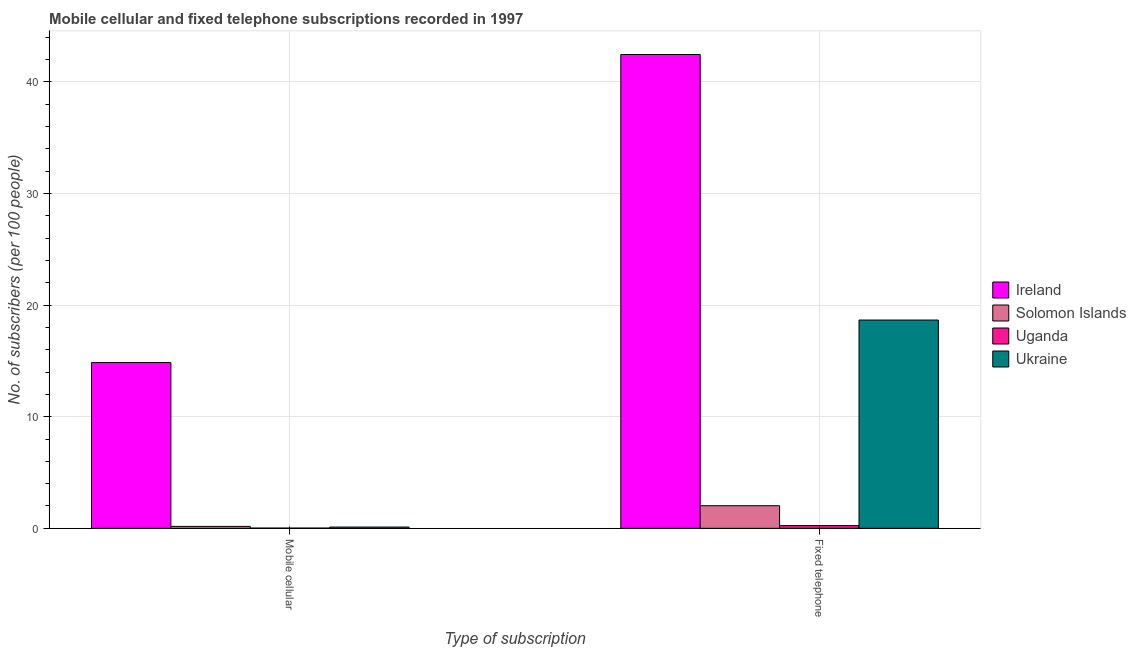Are the number of bars per tick equal to the number of legend labels?
Provide a short and direct response. Yes. How many bars are there on the 1st tick from the left?
Your answer should be compact. 4. What is the label of the 2nd group of bars from the left?
Offer a terse response. Fixed telephone. What is the number of fixed telephone subscribers in Solomon Islands?
Give a very brief answer. 2.03. Across all countries, what is the maximum number of mobile cellular subscribers?
Your answer should be very brief. 14.85. Across all countries, what is the minimum number of mobile cellular subscribers?
Ensure brevity in your answer.  0.02. In which country was the number of fixed telephone subscribers maximum?
Offer a very short reply. Ireland. In which country was the number of mobile cellular subscribers minimum?
Make the answer very short. Uganda. What is the total number of fixed telephone subscribers in the graph?
Your answer should be very brief. 63.39. What is the difference between the number of mobile cellular subscribers in Ireland and that in Uganda?
Make the answer very short. 14.83. What is the difference between the number of mobile cellular subscribers in Uganda and the number of fixed telephone subscribers in Solomon Islands?
Keep it short and to the point. -2. What is the average number of fixed telephone subscribers per country?
Provide a succinct answer. 15.85. What is the difference between the number of fixed telephone subscribers and number of mobile cellular subscribers in Uganda?
Provide a succinct answer. 0.22. What is the ratio of the number of mobile cellular subscribers in Uganda to that in Ireland?
Your answer should be compact. 0. Is the number of fixed telephone subscribers in Ireland less than that in Solomon Islands?
Your answer should be very brief. No. What does the 2nd bar from the left in Fixed telephone represents?
Your response must be concise. Solomon Islands. What does the 2nd bar from the right in Fixed telephone represents?
Your answer should be very brief. Uganda. Are all the bars in the graph horizontal?
Your answer should be very brief. No. Does the graph contain any zero values?
Provide a succinct answer. No. Does the graph contain grids?
Provide a short and direct response. Yes. How many legend labels are there?
Keep it short and to the point. 4. How are the legend labels stacked?
Offer a terse response. Vertical. What is the title of the graph?
Your answer should be compact. Mobile cellular and fixed telephone subscriptions recorded in 1997. Does "Romania" appear as one of the legend labels in the graph?
Ensure brevity in your answer.  No. What is the label or title of the X-axis?
Offer a very short reply. Type of subscription. What is the label or title of the Y-axis?
Make the answer very short. No. of subscribers (per 100 people). What is the No. of subscribers (per 100 people) of Ireland in Mobile cellular?
Your answer should be very brief. 14.85. What is the No. of subscribers (per 100 people) of Solomon Islands in Mobile cellular?
Keep it short and to the point. 0.17. What is the No. of subscribers (per 100 people) in Uganda in Mobile cellular?
Offer a very short reply. 0.02. What is the No. of subscribers (per 100 people) of Ukraine in Mobile cellular?
Your response must be concise. 0.11. What is the No. of subscribers (per 100 people) of Ireland in Fixed telephone?
Your answer should be compact. 42.45. What is the No. of subscribers (per 100 people) in Solomon Islands in Fixed telephone?
Your response must be concise. 2.03. What is the No. of subscribers (per 100 people) in Uganda in Fixed telephone?
Your answer should be very brief. 0.24. What is the No. of subscribers (per 100 people) of Ukraine in Fixed telephone?
Your response must be concise. 18.66. Across all Type of subscription, what is the maximum No. of subscribers (per 100 people) of Ireland?
Make the answer very short. 42.45. Across all Type of subscription, what is the maximum No. of subscribers (per 100 people) in Solomon Islands?
Your answer should be very brief. 2.03. Across all Type of subscription, what is the maximum No. of subscribers (per 100 people) of Uganda?
Your answer should be very brief. 0.24. Across all Type of subscription, what is the maximum No. of subscribers (per 100 people) of Ukraine?
Your response must be concise. 18.66. Across all Type of subscription, what is the minimum No. of subscribers (per 100 people) of Ireland?
Your answer should be very brief. 14.85. Across all Type of subscription, what is the minimum No. of subscribers (per 100 people) in Solomon Islands?
Offer a terse response. 0.17. Across all Type of subscription, what is the minimum No. of subscribers (per 100 people) in Uganda?
Offer a terse response. 0.02. Across all Type of subscription, what is the minimum No. of subscribers (per 100 people) of Ukraine?
Offer a very short reply. 0.11. What is the total No. of subscribers (per 100 people) of Ireland in the graph?
Offer a terse response. 57.31. What is the total No. of subscribers (per 100 people) in Solomon Islands in the graph?
Provide a short and direct response. 2.2. What is the total No. of subscribers (per 100 people) in Uganda in the graph?
Your answer should be very brief. 0.27. What is the total No. of subscribers (per 100 people) of Ukraine in the graph?
Provide a short and direct response. 18.78. What is the difference between the No. of subscribers (per 100 people) in Ireland in Mobile cellular and that in Fixed telephone?
Your answer should be compact. -27.6. What is the difference between the No. of subscribers (per 100 people) in Solomon Islands in Mobile cellular and that in Fixed telephone?
Your answer should be compact. -1.85. What is the difference between the No. of subscribers (per 100 people) of Uganda in Mobile cellular and that in Fixed telephone?
Your answer should be compact. -0.22. What is the difference between the No. of subscribers (per 100 people) of Ukraine in Mobile cellular and that in Fixed telephone?
Provide a succinct answer. -18.55. What is the difference between the No. of subscribers (per 100 people) in Ireland in Mobile cellular and the No. of subscribers (per 100 people) in Solomon Islands in Fixed telephone?
Your response must be concise. 12.83. What is the difference between the No. of subscribers (per 100 people) of Ireland in Mobile cellular and the No. of subscribers (per 100 people) of Uganda in Fixed telephone?
Give a very brief answer. 14.61. What is the difference between the No. of subscribers (per 100 people) of Ireland in Mobile cellular and the No. of subscribers (per 100 people) of Ukraine in Fixed telephone?
Your answer should be very brief. -3.81. What is the difference between the No. of subscribers (per 100 people) in Solomon Islands in Mobile cellular and the No. of subscribers (per 100 people) in Uganda in Fixed telephone?
Offer a terse response. -0.07. What is the difference between the No. of subscribers (per 100 people) in Solomon Islands in Mobile cellular and the No. of subscribers (per 100 people) in Ukraine in Fixed telephone?
Offer a terse response. -18.49. What is the difference between the No. of subscribers (per 100 people) in Uganda in Mobile cellular and the No. of subscribers (per 100 people) in Ukraine in Fixed telephone?
Your response must be concise. -18.64. What is the average No. of subscribers (per 100 people) of Ireland per Type of subscription?
Keep it short and to the point. 28.65. What is the average No. of subscribers (per 100 people) of Solomon Islands per Type of subscription?
Your answer should be very brief. 1.1. What is the average No. of subscribers (per 100 people) in Uganda per Type of subscription?
Ensure brevity in your answer.  0.13. What is the average No. of subscribers (per 100 people) of Ukraine per Type of subscription?
Provide a short and direct response. 9.39. What is the difference between the No. of subscribers (per 100 people) in Ireland and No. of subscribers (per 100 people) in Solomon Islands in Mobile cellular?
Give a very brief answer. 14.68. What is the difference between the No. of subscribers (per 100 people) of Ireland and No. of subscribers (per 100 people) of Uganda in Mobile cellular?
Make the answer very short. 14.83. What is the difference between the No. of subscribers (per 100 people) of Ireland and No. of subscribers (per 100 people) of Ukraine in Mobile cellular?
Your response must be concise. 14.74. What is the difference between the No. of subscribers (per 100 people) in Solomon Islands and No. of subscribers (per 100 people) in Uganda in Mobile cellular?
Provide a succinct answer. 0.15. What is the difference between the No. of subscribers (per 100 people) in Solomon Islands and No. of subscribers (per 100 people) in Ukraine in Mobile cellular?
Your response must be concise. 0.06. What is the difference between the No. of subscribers (per 100 people) of Uganda and No. of subscribers (per 100 people) of Ukraine in Mobile cellular?
Ensure brevity in your answer.  -0.09. What is the difference between the No. of subscribers (per 100 people) in Ireland and No. of subscribers (per 100 people) in Solomon Islands in Fixed telephone?
Offer a terse response. 40.43. What is the difference between the No. of subscribers (per 100 people) in Ireland and No. of subscribers (per 100 people) in Uganda in Fixed telephone?
Give a very brief answer. 42.21. What is the difference between the No. of subscribers (per 100 people) in Ireland and No. of subscribers (per 100 people) in Ukraine in Fixed telephone?
Your answer should be compact. 23.79. What is the difference between the No. of subscribers (per 100 people) of Solomon Islands and No. of subscribers (per 100 people) of Uganda in Fixed telephone?
Offer a very short reply. 1.78. What is the difference between the No. of subscribers (per 100 people) of Solomon Islands and No. of subscribers (per 100 people) of Ukraine in Fixed telephone?
Ensure brevity in your answer.  -16.64. What is the difference between the No. of subscribers (per 100 people) of Uganda and No. of subscribers (per 100 people) of Ukraine in Fixed telephone?
Offer a very short reply. -18.42. What is the ratio of the No. of subscribers (per 100 people) of Ireland in Mobile cellular to that in Fixed telephone?
Keep it short and to the point. 0.35. What is the ratio of the No. of subscribers (per 100 people) of Solomon Islands in Mobile cellular to that in Fixed telephone?
Your answer should be very brief. 0.09. What is the ratio of the No. of subscribers (per 100 people) in Uganda in Mobile cellular to that in Fixed telephone?
Provide a succinct answer. 0.09. What is the ratio of the No. of subscribers (per 100 people) in Ukraine in Mobile cellular to that in Fixed telephone?
Give a very brief answer. 0.01. What is the difference between the highest and the second highest No. of subscribers (per 100 people) in Ireland?
Make the answer very short. 27.6. What is the difference between the highest and the second highest No. of subscribers (per 100 people) in Solomon Islands?
Provide a succinct answer. 1.85. What is the difference between the highest and the second highest No. of subscribers (per 100 people) of Uganda?
Give a very brief answer. 0.22. What is the difference between the highest and the second highest No. of subscribers (per 100 people) in Ukraine?
Make the answer very short. 18.55. What is the difference between the highest and the lowest No. of subscribers (per 100 people) in Ireland?
Provide a short and direct response. 27.6. What is the difference between the highest and the lowest No. of subscribers (per 100 people) of Solomon Islands?
Give a very brief answer. 1.85. What is the difference between the highest and the lowest No. of subscribers (per 100 people) of Uganda?
Ensure brevity in your answer.  0.22. What is the difference between the highest and the lowest No. of subscribers (per 100 people) in Ukraine?
Keep it short and to the point. 18.55. 